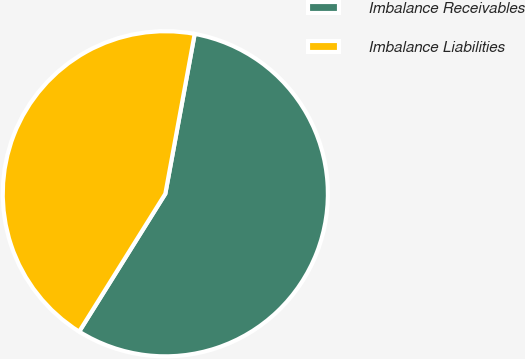<chart> <loc_0><loc_0><loc_500><loc_500><pie_chart><fcel>Imbalance Receivables<fcel>Imbalance Liabilities<nl><fcel>56.0%<fcel>44.0%<nl></chart> 